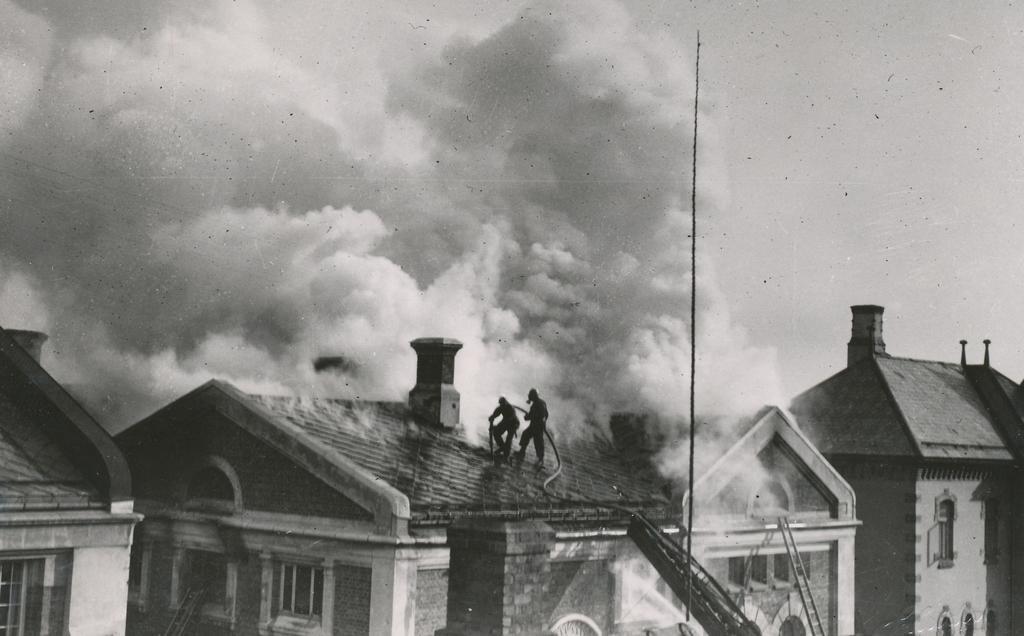Please provide a concise description of this image. In this picture I can see houses, there is a ladder, there are two persons holding a pipe and standing on the roof of a house, there is smoke, and in the background there is sky. 